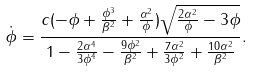<formula> <loc_0><loc_0><loc_500><loc_500>\dot { \phi } = \frac { c ( - \phi + \frac { \phi ^ { 3 } } { \beta ^ { 2 } } + \frac { \alpha ^ { 2 } } { \phi } ) \sqrt { \frac { 2 \alpha ^ { 2 } } { \phi } - 3 \phi } } { 1 - \frac { 2 \alpha ^ { 4 } } { 3 \phi ^ { 4 } } - \frac { 9 \phi ^ { 2 } } { \beta ^ { 2 } } + \frac { 7 \alpha ^ { 2 } } { 3 \phi ^ { 2 } } + \frac { 1 0 \alpha ^ { 2 } } { \beta ^ { 2 } } } .</formula> 